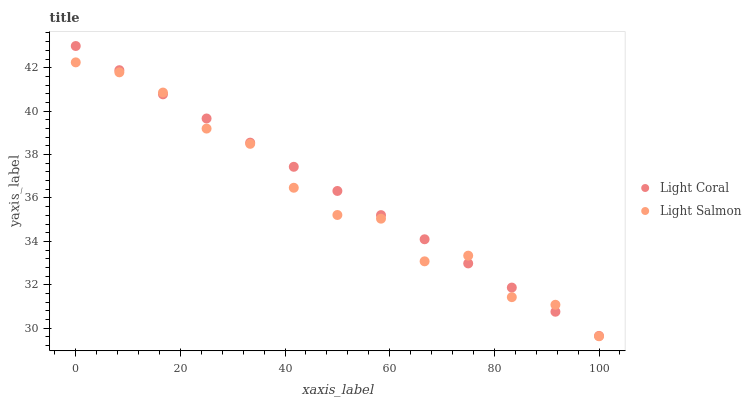Does Light Salmon have the minimum area under the curve?
Answer yes or no. Yes. Does Light Coral have the maximum area under the curve?
Answer yes or no. Yes. Does Light Salmon have the maximum area under the curve?
Answer yes or no. No. Is Light Coral the smoothest?
Answer yes or no. Yes. Is Light Salmon the roughest?
Answer yes or no. Yes. Is Light Salmon the smoothest?
Answer yes or no. No. Does Light Salmon have the lowest value?
Answer yes or no. Yes. Does Light Coral have the highest value?
Answer yes or no. Yes. Does Light Salmon have the highest value?
Answer yes or no. No. Does Light Salmon intersect Light Coral?
Answer yes or no. Yes. Is Light Salmon less than Light Coral?
Answer yes or no. No. Is Light Salmon greater than Light Coral?
Answer yes or no. No. 